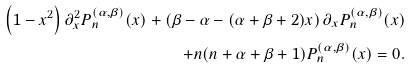<formula> <loc_0><loc_0><loc_500><loc_500>\left ( 1 - x ^ { 2 } \right ) \partial _ { x } ^ { 2 } P _ { n } ^ { ( \alpha , \beta ) } ( x ) + \left ( \beta - \alpha - ( \alpha + \beta + 2 ) x \right ) \partial _ { x } P _ { n } ^ { ( \alpha , \beta ) } ( x ) \\ + n ( n + \alpha + \beta + 1 ) P _ { n } ^ { ( \alpha , \beta ) } ( x ) = 0 .</formula> 